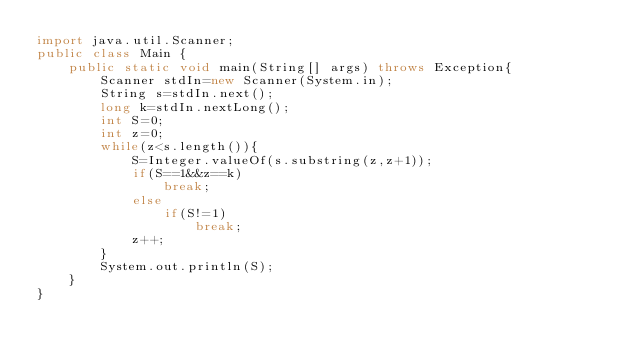Convert code to text. <code><loc_0><loc_0><loc_500><loc_500><_Java_>import java.util.Scanner;
public class Main {
	public static void main(String[] args) throws Exception{
		Scanner stdIn=new Scanner(System.in);
		String s=stdIn.next();
		long k=stdIn.nextLong();
		int S=0;
		int z=0;
		while(z<s.length()){
			S=Integer.valueOf(s.substring(z,z+1));
			if(S==1&&z==k)
				break;
			else
				if(S!=1)
					break;
			z++;
		}
		System.out.println(S);
	}
}</code> 